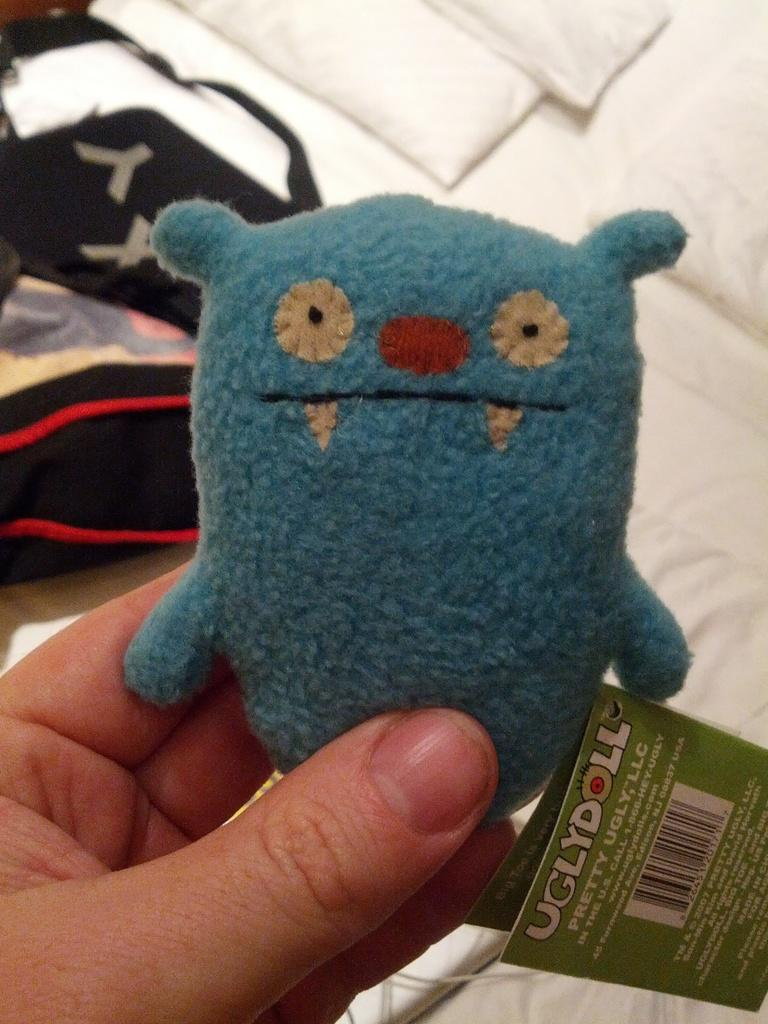What is the main subject of the image? There is a person in the image. What is the person holding in the image? The person is holding a toy. Is there any additional information about the toy? Yes, there is a tag attached to the toy. What type of button is the beggar using to detonate the bomb in the image? There is no beggar, button, or bomb present in the image. The image only features a person holding a toy with a tag attached to it. 